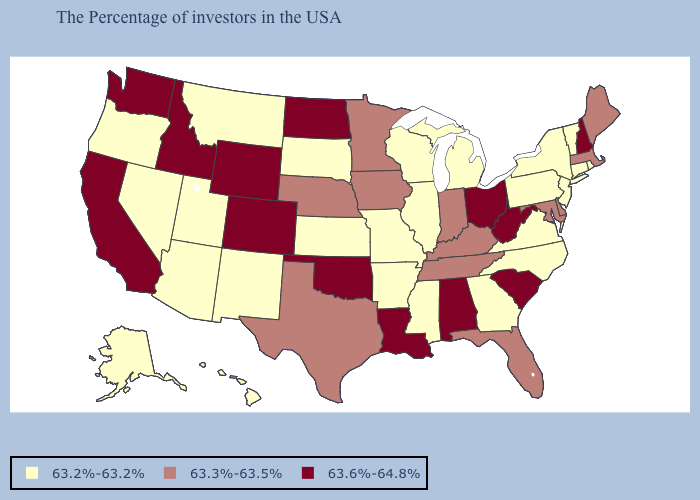What is the value of Indiana?
Short answer required. 63.3%-63.5%. What is the highest value in states that border South Dakota?
Write a very short answer. 63.6%-64.8%. What is the value of New York?
Quick response, please. 63.2%-63.2%. What is the lowest value in the USA?
Concise answer only. 63.2%-63.2%. Does Arizona have the highest value in the USA?
Quick response, please. No. Does Missouri have the lowest value in the USA?
Short answer required. Yes. What is the value of West Virginia?
Short answer required. 63.6%-64.8%. What is the value of Nevada?
Answer briefly. 63.2%-63.2%. Name the states that have a value in the range 63.3%-63.5%?
Concise answer only. Maine, Massachusetts, Delaware, Maryland, Florida, Kentucky, Indiana, Tennessee, Minnesota, Iowa, Nebraska, Texas. Name the states that have a value in the range 63.6%-64.8%?
Concise answer only. New Hampshire, South Carolina, West Virginia, Ohio, Alabama, Louisiana, Oklahoma, North Dakota, Wyoming, Colorado, Idaho, California, Washington. What is the lowest value in the USA?
Answer briefly. 63.2%-63.2%. Name the states that have a value in the range 63.3%-63.5%?
Concise answer only. Maine, Massachusetts, Delaware, Maryland, Florida, Kentucky, Indiana, Tennessee, Minnesota, Iowa, Nebraska, Texas. Does Arizona have a lower value than Minnesota?
Be succinct. Yes. What is the value of New York?
Give a very brief answer. 63.2%-63.2%. How many symbols are there in the legend?
Concise answer only. 3. 